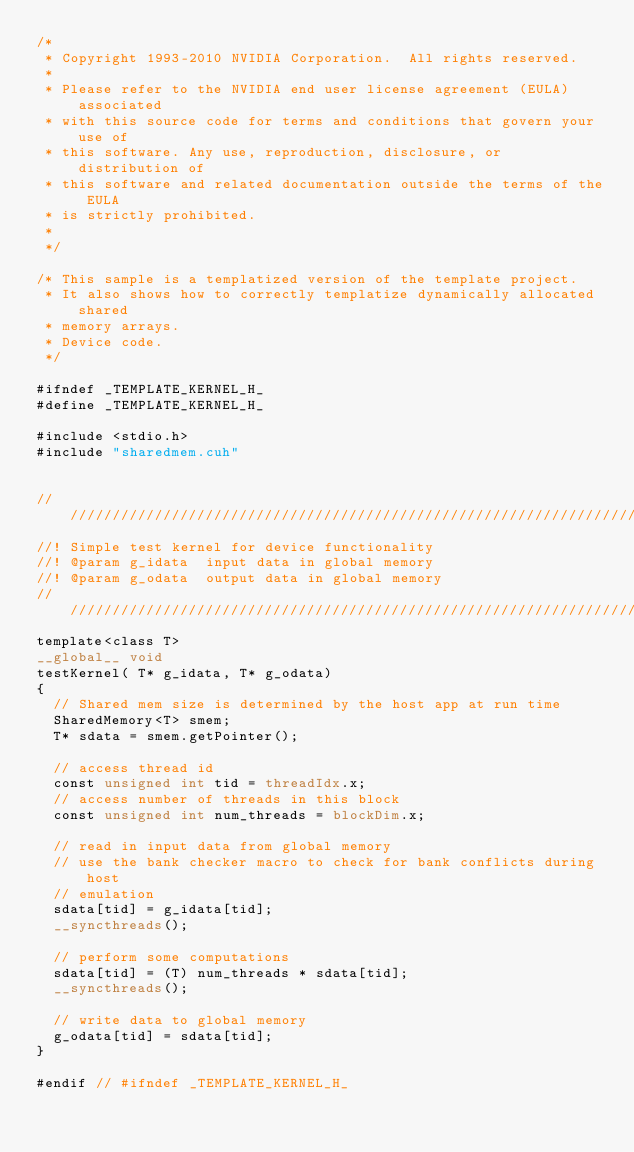<code> <loc_0><loc_0><loc_500><loc_500><_Cuda_>/*
 * Copyright 1993-2010 NVIDIA Corporation.  All rights reserved.
 *
 * Please refer to the NVIDIA end user license agreement (EULA) associated
 * with this source code for terms and conditions that govern your use of
 * this software. Any use, reproduction, disclosure, or distribution of
 * this software and related documentation outside the terms of the EULA
 * is strictly prohibited.
 *
 */

/* This sample is a templatized version of the template project.
 * It also shows how to correctly templatize dynamically allocated shared
 * memory arrays.
 * Device code.
 */

#ifndef _TEMPLATE_KERNEL_H_
#define _TEMPLATE_KERNEL_H_

#include <stdio.h>
#include "sharedmem.cuh"


////////////////////////////////////////////////////////////////////////////////
//! Simple test kernel for device functionality
//! @param g_idata  input data in global memory
//! @param g_odata  output data in global memory
////////////////////////////////////////////////////////////////////////////////
template<class T>
__global__ void
testKernel( T* g_idata, T* g_odata) 
{
  // Shared mem size is determined by the host app at run time
  SharedMemory<T> smem;
  T* sdata = smem.getPointer();

  // access thread id
  const unsigned int tid = threadIdx.x;
  // access number of threads in this block
  const unsigned int num_threads = blockDim.x;

  // read in input data from global memory
  // use the bank checker macro to check for bank conflicts during host
  // emulation
  sdata[tid] = g_idata[tid];
  __syncthreads();

  // perform some computations
  sdata[tid] = (T) num_threads * sdata[tid];
  __syncthreads();

  // write data to global memory
  g_odata[tid] = sdata[tid];
}

#endif // #ifndef _TEMPLATE_KERNEL_H_
</code> 